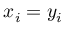Convert formula to latex. <formula><loc_0><loc_0><loc_500><loc_500>x _ { i } = y _ { i }</formula> 